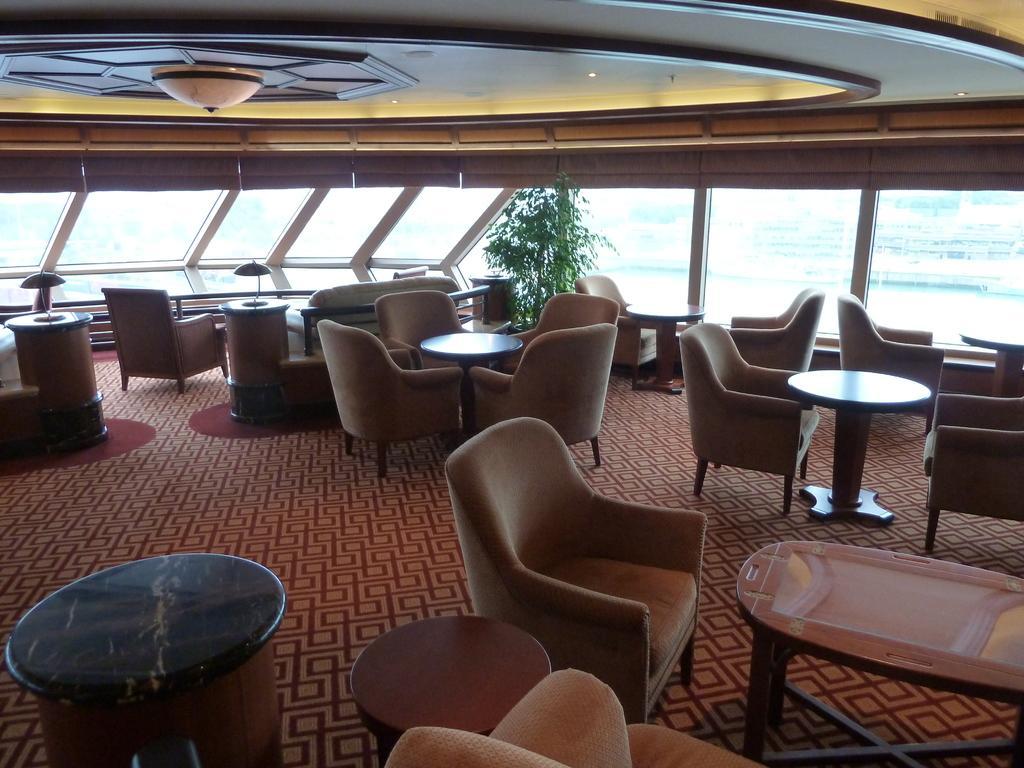Please provide a concise description of this image. This image is taken from inside the boat where tables and chairs are kept. In the middle of the image, a houseplant is there. In the middle background, a blue color water is visible. A roof top is white yellow in color and a chandelier is attached to that. 